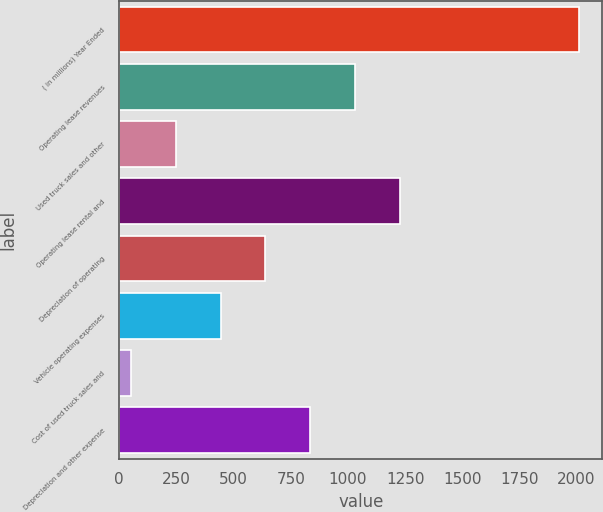<chart> <loc_0><loc_0><loc_500><loc_500><bar_chart><fcel>( in millions) Year Ended<fcel>Operating lease revenues<fcel>Used truck sales and other<fcel>Operating lease rental and<fcel>Depreciation of operating<fcel>Vehicle operating expenses<fcel>Cost of used truck sales and<fcel>Depreciation and other expense<nl><fcel>2012<fcel>1031.25<fcel>246.65<fcel>1227.4<fcel>638.95<fcel>442.8<fcel>50.5<fcel>835.1<nl></chart> 